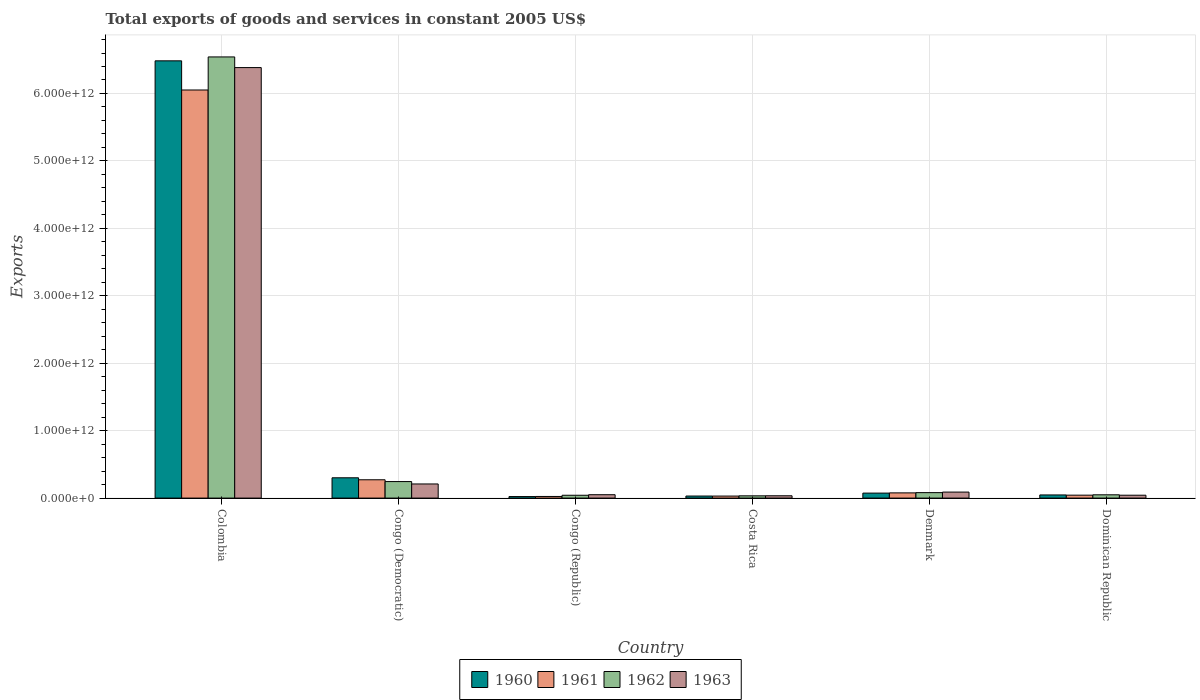Are the number of bars per tick equal to the number of legend labels?
Your answer should be very brief. Yes. Are the number of bars on each tick of the X-axis equal?
Your answer should be compact. Yes. How many bars are there on the 4th tick from the left?
Provide a short and direct response. 4. How many bars are there on the 1st tick from the right?
Your answer should be very brief. 4. What is the label of the 2nd group of bars from the left?
Provide a short and direct response. Congo (Democratic). What is the total exports of goods and services in 1962 in Denmark?
Offer a terse response. 8.10e+1. Across all countries, what is the maximum total exports of goods and services in 1961?
Provide a short and direct response. 6.05e+12. Across all countries, what is the minimum total exports of goods and services in 1960?
Offer a terse response. 2.25e+1. In which country was the total exports of goods and services in 1961 minimum?
Your response must be concise. Congo (Republic). What is the total total exports of goods and services in 1960 in the graph?
Your answer should be very brief. 6.96e+12. What is the difference between the total exports of goods and services in 1961 in Colombia and that in Denmark?
Keep it short and to the point. 5.97e+12. What is the difference between the total exports of goods and services in 1961 in Congo (Democratic) and the total exports of goods and services in 1962 in Congo (Republic)?
Your answer should be very brief. 2.30e+11. What is the average total exports of goods and services in 1960 per country?
Your answer should be very brief. 1.16e+12. What is the difference between the total exports of goods and services of/in 1962 and total exports of goods and services of/in 1963 in Costa Rica?
Your response must be concise. -8.49e+08. In how many countries, is the total exports of goods and services in 1963 greater than 200000000000 US$?
Offer a very short reply. 2. What is the ratio of the total exports of goods and services in 1963 in Congo (Democratic) to that in Denmark?
Make the answer very short. 2.35. Is the difference between the total exports of goods and services in 1962 in Denmark and Dominican Republic greater than the difference between the total exports of goods and services in 1963 in Denmark and Dominican Republic?
Your answer should be very brief. No. What is the difference between the highest and the second highest total exports of goods and services in 1960?
Offer a terse response. 6.41e+12. What is the difference between the highest and the lowest total exports of goods and services in 1962?
Give a very brief answer. 6.51e+12. In how many countries, is the total exports of goods and services in 1961 greater than the average total exports of goods and services in 1961 taken over all countries?
Your response must be concise. 1. Is the sum of the total exports of goods and services in 1963 in Costa Rica and Denmark greater than the maximum total exports of goods and services in 1960 across all countries?
Your answer should be very brief. No. What does the 4th bar from the left in Colombia represents?
Offer a terse response. 1963. How many bars are there?
Provide a succinct answer. 24. How many countries are there in the graph?
Make the answer very short. 6. What is the difference between two consecutive major ticks on the Y-axis?
Your answer should be very brief. 1.00e+12. Where does the legend appear in the graph?
Provide a succinct answer. Bottom center. How are the legend labels stacked?
Your response must be concise. Horizontal. What is the title of the graph?
Your response must be concise. Total exports of goods and services in constant 2005 US$. What is the label or title of the Y-axis?
Offer a very short reply. Exports. What is the Exports of 1960 in Colombia?
Provide a succinct answer. 6.48e+12. What is the Exports in 1961 in Colombia?
Your response must be concise. 6.05e+12. What is the Exports of 1962 in Colombia?
Your answer should be very brief. 6.54e+12. What is the Exports in 1963 in Colombia?
Provide a succinct answer. 6.38e+12. What is the Exports in 1960 in Congo (Democratic)?
Give a very brief answer. 3.01e+11. What is the Exports in 1961 in Congo (Democratic)?
Give a very brief answer. 2.72e+11. What is the Exports in 1962 in Congo (Democratic)?
Give a very brief answer. 2.45e+11. What is the Exports of 1963 in Congo (Democratic)?
Your response must be concise. 2.09e+11. What is the Exports in 1960 in Congo (Republic)?
Your answer should be compact. 2.25e+1. What is the Exports of 1961 in Congo (Republic)?
Give a very brief answer. 2.42e+1. What is the Exports of 1962 in Congo (Republic)?
Keep it short and to the point. 4.20e+1. What is the Exports of 1963 in Congo (Republic)?
Your answer should be compact. 5.01e+1. What is the Exports of 1960 in Costa Rica?
Your response must be concise. 3.05e+1. What is the Exports in 1961 in Costa Rica?
Ensure brevity in your answer.  3.00e+1. What is the Exports in 1962 in Costa Rica?
Keep it short and to the point. 3.35e+1. What is the Exports in 1963 in Costa Rica?
Keep it short and to the point. 3.44e+1. What is the Exports of 1960 in Denmark?
Provide a succinct answer. 7.40e+1. What is the Exports of 1961 in Denmark?
Make the answer very short. 7.72e+1. What is the Exports of 1962 in Denmark?
Ensure brevity in your answer.  8.10e+1. What is the Exports in 1963 in Denmark?
Your answer should be very brief. 8.91e+1. What is the Exports in 1960 in Dominican Republic?
Offer a terse response. 4.67e+1. What is the Exports of 1961 in Dominican Republic?
Keep it short and to the point. 4.34e+1. What is the Exports in 1962 in Dominican Republic?
Provide a short and direct response. 4.87e+1. What is the Exports in 1963 in Dominican Republic?
Make the answer very short. 4.28e+1. Across all countries, what is the maximum Exports of 1960?
Keep it short and to the point. 6.48e+12. Across all countries, what is the maximum Exports of 1961?
Ensure brevity in your answer.  6.05e+12. Across all countries, what is the maximum Exports in 1962?
Your answer should be very brief. 6.54e+12. Across all countries, what is the maximum Exports in 1963?
Offer a terse response. 6.38e+12. Across all countries, what is the minimum Exports of 1960?
Your answer should be compact. 2.25e+1. Across all countries, what is the minimum Exports of 1961?
Give a very brief answer. 2.42e+1. Across all countries, what is the minimum Exports of 1962?
Your response must be concise. 3.35e+1. Across all countries, what is the minimum Exports in 1963?
Your response must be concise. 3.44e+1. What is the total Exports of 1960 in the graph?
Your answer should be very brief. 6.96e+12. What is the total Exports of 1961 in the graph?
Offer a very short reply. 6.50e+12. What is the total Exports of 1962 in the graph?
Make the answer very short. 6.99e+12. What is the total Exports of 1963 in the graph?
Your response must be concise. 6.81e+12. What is the difference between the Exports in 1960 in Colombia and that in Congo (Democratic)?
Provide a short and direct response. 6.18e+12. What is the difference between the Exports in 1961 in Colombia and that in Congo (Democratic)?
Your response must be concise. 5.78e+12. What is the difference between the Exports of 1962 in Colombia and that in Congo (Democratic)?
Make the answer very short. 6.30e+12. What is the difference between the Exports in 1963 in Colombia and that in Congo (Democratic)?
Provide a short and direct response. 6.17e+12. What is the difference between the Exports in 1960 in Colombia and that in Congo (Republic)?
Keep it short and to the point. 6.46e+12. What is the difference between the Exports in 1961 in Colombia and that in Congo (Republic)?
Your answer should be compact. 6.03e+12. What is the difference between the Exports of 1962 in Colombia and that in Congo (Republic)?
Your answer should be compact. 6.50e+12. What is the difference between the Exports in 1963 in Colombia and that in Congo (Republic)?
Give a very brief answer. 6.33e+12. What is the difference between the Exports in 1960 in Colombia and that in Costa Rica?
Keep it short and to the point. 6.45e+12. What is the difference between the Exports in 1961 in Colombia and that in Costa Rica?
Offer a very short reply. 6.02e+12. What is the difference between the Exports of 1962 in Colombia and that in Costa Rica?
Your response must be concise. 6.51e+12. What is the difference between the Exports in 1963 in Colombia and that in Costa Rica?
Your answer should be very brief. 6.35e+12. What is the difference between the Exports of 1960 in Colombia and that in Denmark?
Ensure brevity in your answer.  6.41e+12. What is the difference between the Exports in 1961 in Colombia and that in Denmark?
Offer a terse response. 5.97e+12. What is the difference between the Exports of 1962 in Colombia and that in Denmark?
Your answer should be compact. 6.46e+12. What is the difference between the Exports in 1963 in Colombia and that in Denmark?
Make the answer very short. 6.29e+12. What is the difference between the Exports in 1960 in Colombia and that in Dominican Republic?
Your response must be concise. 6.44e+12. What is the difference between the Exports in 1961 in Colombia and that in Dominican Republic?
Give a very brief answer. 6.01e+12. What is the difference between the Exports of 1962 in Colombia and that in Dominican Republic?
Ensure brevity in your answer.  6.49e+12. What is the difference between the Exports of 1963 in Colombia and that in Dominican Republic?
Offer a very short reply. 6.34e+12. What is the difference between the Exports of 1960 in Congo (Democratic) and that in Congo (Republic)?
Give a very brief answer. 2.79e+11. What is the difference between the Exports of 1961 in Congo (Democratic) and that in Congo (Republic)?
Your answer should be compact. 2.48e+11. What is the difference between the Exports of 1962 in Congo (Democratic) and that in Congo (Republic)?
Keep it short and to the point. 2.03e+11. What is the difference between the Exports of 1963 in Congo (Democratic) and that in Congo (Republic)?
Make the answer very short. 1.59e+11. What is the difference between the Exports of 1960 in Congo (Democratic) and that in Costa Rica?
Your answer should be compact. 2.71e+11. What is the difference between the Exports of 1961 in Congo (Democratic) and that in Costa Rica?
Your answer should be very brief. 2.42e+11. What is the difference between the Exports in 1962 in Congo (Democratic) and that in Costa Rica?
Offer a very short reply. 2.11e+11. What is the difference between the Exports in 1963 in Congo (Democratic) and that in Costa Rica?
Offer a terse response. 1.75e+11. What is the difference between the Exports in 1960 in Congo (Democratic) and that in Denmark?
Keep it short and to the point. 2.27e+11. What is the difference between the Exports of 1961 in Congo (Democratic) and that in Denmark?
Offer a very short reply. 1.95e+11. What is the difference between the Exports of 1962 in Congo (Democratic) and that in Denmark?
Your response must be concise. 1.64e+11. What is the difference between the Exports of 1963 in Congo (Democratic) and that in Denmark?
Your answer should be very brief. 1.20e+11. What is the difference between the Exports in 1960 in Congo (Democratic) and that in Dominican Republic?
Your answer should be very brief. 2.54e+11. What is the difference between the Exports of 1961 in Congo (Democratic) and that in Dominican Republic?
Your response must be concise. 2.28e+11. What is the difference between the Exports of 1962 in Congo (Democratic) and that in Dominican Republic?
Your answer should be very brief. 1.96e+11. What is the difference between the Exports of 1963 in Congo (Democratic) and that in Dominican Republic?
Offer a very short reply. 1.67e+11. What is the difference between the Exports of 1960 in Congo (Republic) and that in Costa Rica?
Offer a very short reply. -7.99e+09. What is the difference between the Exports in 1961 in Congo (Republic) and that in Costa Rica?
Your response must be concise. -5.74e+09. What is the difference between the Exports in 1962 in Congo (Republic) and that in Costa Rica?
Your answer should be very brief. 8.51e+09. What is the difference between the Exports in 1963 in Congo (Republic) and that in Costa Rica?
Offer a very short reply. 1.57e+1. What is the difference between the Exports in 1960 in Congo (Republic) and that in Denmark?
Make the answer very short. -5.15e+1. What is the difference between the Exports of 1961 in Congo (Republic) and that in Denmark?
Provide a succinct answer. -5.30e+1. What is the difference between the Exports of 1962 in Congo (Republic) and that in Denmark?
Provide a succinct answer. -3.90e+1. What is the difference between the Exports of 1963 in Congo (Republic) and that in Denmark?
Offer a terse response. -3.90e+1. What is the difference between the Exports of 1960 in Congo (Republic) and that in Dominican Republic?
Ensure brevity in your answer.  -2.42e+1. What is the difference between the Exports of 1961 in Congo (Republic) and that in Dominican Republic?
Offer a very short reply. -1.92e+1. What is the difference between the Exports of 1962 in Congo (Republic) and that in Dominican Republic?
Provide a short and direct response. -6.63e+09. What is the difference between the Exports in 1963 in Congo (Republic) and that in Dominican Republic?
Provide a short and direct response. 7.33e+09. What is the difference between the Exports in 1960 in Costa Rica and that in Denmark?
Your answer should be very brief. -4.35e+1. What is the difference between the Exports of 1961 in Costa Rica and that in Denmark?
Give a very brief answer. -4.73e+1. What is the difference between the Exports in 1962 in Costa Rica and that in Denmark?
Your answer should be compact. -4.75e+1. What is the difference between the Exports of 1963 in Costa Rica and that in Denmark?
Make the answer very short. -5.47e+1. What is the difference between the Exports of 1960 in Costa Rica and that in Dominican Republic?
Ensure brevity in your answer.  -1.62e+1. What is the difference between the Exports of 1961 in Costa Rica and that in Dominican Republic?
Provide a short and direct response. -1.35e+1. What is the difference between the Exports in 1962 in Costa Rica and that in Dominican Republic?
Provide a succinct answer. -1.51e+1. What is the difference between the Exports in 1963 in Costa Rica and that in Dominican Republic?
Offer a very short reply. -8.40e+09. What is the difference between the Exports of 1960 in Denmark and that in Dominican Republic?
Make the answer very short. 2.73e+1. What is the difference between the Exports in 1961 in Denmark and that in Dominican Republic?
Make the answer very short. 3.38e+1. What is the difference between the Exports in 1962 in Denmark and that in Dominican Republic?
Your answer should be compact. 3.23e+1. What is the difference between the Exports of 1963 in Denmark and that in Dominican Republic?
Your answer should be very brief. 4.63e+1. What is the difference between the Exports of 1960 in Colombia and the Exports of 1961 in Congo (Democratic)?
Your answer should be compact. 6.21e+12. What is the difference between the Exports of 1960 in Colombia and the Exports of 1962 in Congo (Democratic)?
Offer a terse response. 6.24e+12. What is the difference between the Exports of 1960 in Colombia and the Exports of 1963 in Congo (Democratic)?
Keep it short and to the point. 6.27e+12. What is the difference between the Exports of 1961 in Colombia and the Exports of 1962 in Congo (Democratic)?
Ensure brevity in your answer.  5.81e+12. What is the difference between the Exports in 1961 in Colombia and the Exports in 1963 in Congo (Democratic)?
Provide a short and direct response. 5.84e+12. What is the difference between the Exports of 1962 in Colombia and the Exports of 1963 in Congo (Democratic)?
Your answer should be compact. 6.33e+12. What is the difference between the Exports in 1960 in Colombia and the Exports in 1961 in Congo (Republic)?
Offer a very short reply. 6.46e+12. What is the difference between the Exports of 1960 in Colombia and the Exports of 1962 in Congo (Republic)?
Give a very brief answer. 6.44e+12. What is the difference between the Exports of 1960 in Colombia and the Exports of 1963 in Congo (Republic)?
Your answer should be very brief. 6.43e+12. What is the difference between the Exports of 1961 in Colombia and the Exports of 1962 in Congo (Republic)?
Offer a terse response. 6.01e+12. What is the difference between the Exports of 1961 in Colombia and the Exports of 1963 in Congo (Republic)?
Keep it short and to the point. 6.00e+12. What is the difference between the Exports of 1962 in Colombia and the Exports of 1963 in Congo (Republic)?
Your response must be concise. 6.49e+12. What is the difference between the Exports in 1960 in Colombia and the Exports in 1961 in Costa Rica?
Offer a very short reply. 6.45e+12. What is the difference between the Exports of 1960 in Colombia and the Exports of 1962 in Costa Rica?
Ensure brevity in your answer.  6.45e+12. What is the difference between the Exports of 1960 in Colombia and the Exports of 1963 in Costa Rica?
Your answer should be very brief. 6.45e+12. What is the difference between the Exports of 1961 in Colombia and the Exports of 1962 in Costa Rica?
Give a very brief answer. 6.02e+12. What is the difference between the Exports in 1961 in Colombia and the Exports in 1963 in Costa Rica?
Provide a short and direct response. 6.02e+12. What is the difference between the Exports of 1962 in Colombia and the Exports of 1963 in Costa Rica?
Your answer should be very brief. 6.51e+12. What is the difference between the Exports of 1960 in Colombia and the Exports of 1961 in Denmark?
Offer a very short reply. 6.41e+12. What is the difference between the Exports of 1960 in Colombia and the Exports of 1962 in Denmark?
Make the answer very short. 6.40e+12. What is the difference between the Exports in 1960 in Colombia and the Exports in 1963 in Denmark?
Provide a short and direct response. 6.40e+12. What is the difference between the Exports in 1961 in Colombia and the Exports in 1962 in Denmark?
Ensure brevity in your answer.  5.97e+12. What is the difference between the Exports in 1961 in Colombia and the Exports in 1963 in Denmark?
Your answer should be very brief. 5.96e+12. What is the difference between the Exports in 1962 in Colombia and the Exports in 1963 in Denmark?
Provide a succinct answer. 6.45e+12. What is the difference between the Exports in 1960 in Colombia and the Exports in 1961 in Dominican Republic?
Ensure brevity in your answer.  6.44e+12. What is the difference between the Exports of 1960 in Colombia and the Exports of 1962 in Dominican Republic?
Offer a terse response. 6.44e+12. What is the difference between the Exports of 1960 in Colombia and the Exports of 1963 in Dominican Republic?
Keep it short and to the point. 6.44e+12. What is the difference between the Exports in 1961 in Colombia and the Exports in 1962 in Dominican Republic?
Make the answer very short. 6.00e+12. What is the difference between the Exports in 1961 in Colombia and the Exports in 1963 in Dominican Republic?
Offer a terse response. 6.01e+12. What is the difference between the Exports in 1962 in Colombia and the Exports in 1963 in Dominican Republic?
Ensure brevity in your answer.  6.50e+12. What is the difference between the Exports in 1960 in Congo (Democratic) and the Exports in 1961 in Congo (Republic)?
Provide a succinct answer. 2.77e+11. What is the difference between the Exports in 1960 in Congo (Democratic) and the Exports in 1962 in Congo (Republic)?
Provide a succinct answer. 2.59e+11. What is the difference between the Exports in 1960 in Congo (Democratic) and the Exports in 1963 in Congo (Republic)?
Ensure brevity in your answer.  2.51e+11. What is the difference between the Exports of 1961 in Congo (Democratic) and the Exports of 1962 in Congo (Republic)?
Offer a terse response. 2.30e+11. What is the difference between the Exports of 1961 in Congo (Democratic) and the Exports of 1963 in Congo (Republic)?
Provide a short and direct response. 2.22e+11. What is the difference between the Exports of 1962 in Congo (Democratic) and the Exports of 1963 in Congo (Republic)?
Your response must be concise. 1.95e+11. What is the difference between the Exports in 1960 in Congo (Democratic) and the Exports in 1961 in Costa Rica?
Provide a succinct answer. 2.71e+11. What is the difference between the Exports of 1960 in Congo (Democratic) and the Exports of 1962 in Costa Rica?
Your answer should be compact. 2.68e+11. What is the difference between the Exports in 1960 in Congo (Democratic) and the Exports in 1963 in Costa Rica?
Make the answer very short. 2.67e+11. What is the difference between the Exports of 1961 in Congo (Democratic) and the Exports of 1962 in Costa Rica?
Your answer should be compact. 2.38e+11. What is the difference between the Exports in 1961 in Congo (Democratic) and the Exports in 1963 in Costa Rica?
Make the answer very short. 2.37e+11. What is the difference between the Exports in 1962 in Congo (Democratic) and the Exports in 1963 in Costa Rica?
Your answer should be compact. 2.11e+11. What is the difference between the Exports of 1960 in Congo (Democratic) and the Exports of 1961 in Denmark?
Keep it short and to the point. 2.24e+11. What is the difference between the Exports of 1960 in Congo (Democratic) and the Exports of 1962 in Denmark?
Give a very brief answer. 2.20e+11. What is the difference between the Exports in 1960 in Congo (Democratic) and the Exports in 1963 in Denmark?
Your response must be concise. 2.12e+11. What is the difference between the Exports in 1961 in Congo (Democratic) and the Exports in 1962 in Denmark?
Offer a very short reply. 1.91e+11. What is the difference between the Exports of 1961 in Congo (Democratic) and the Exports of 1963 in Denmark?
Your response must be concise. 1.83e+11. What is the difference between the Exports in 1962 in Congo (Democratic) and the Exports in 1963 in Denmark?
Your response must be concise. 1.56e+11. What is the difference between the Exports of 1960 in Congo (Democratic) and the Exports of 1961 in Dominican Republic?
Make the answer very short. 2.58e+11. What is the difference between the Exports of 1960 in Congo (Democratic) and the Exports of 1962 in Dominican Republic?
Provide a succinct answer. 2.52e+11. What is the difference between the Exports in 1960 in Congo (Democratic) and the Exports in 1963 in Dominican Republic?
Keep it short and to the point. 2.58e+11. What is the difference between the Exports of 1961 in Congo (Democratic) and the Exports of 1962 in Dominican Republic?
Make the answer very short. 2.23e+11. What is the difference between the Exports of 1961 in Congo (Democratic) and the Exports of 1963 in Dominican Republic?
Your response must be concise. 2.29e+11. What is the difference between the Exports of 1962 in Congo (Democratic) and the Exports of 1963 in Dominican Republic?
Your answer should be compact. 2.02e+11. What is the difference between the Exports of 1960 in Congo (Republic) and the Exports of 1961 in Costa Rica?
Provide a short and direct response. -7.43e+09. What is the difference between the Exports of 1960 in Congo (Republic) and the Exports of 1962 in Costa Rica?
Give a very brief answer. -1.10e+1. What is the difference between the Exports of 1960 in Congo (Republic) and the Exports of 1963 in Costa Rica?
Offer a very short reply. -1.19e+1. What is the difference between the Exports of 1961 in Congo (Republic) and the Exports of 1962 in Costa Rica?
Give a very brief answer. -9.32e+09. What is the difference between the Exports of 1961 in Congo (Republic) and the Exports of 1963 in Costa Rica?
Give a very brief answer. -1.02e+1. What is the difference between the Exports in 1962 in Congo (Republic) and the Exports in 1963 in Costa Rica?
Provide a succinct answer. 7.66e+09. What is the difference between the Exports in 1960 in Congo (Republic) and the Exports in 1961 in Denmark?
Keep it short and to the point. -5.47e+1. What is the difference between the Exports of 1960 in Congo (Republic) and the Exports of 1962 in Denmark?
Offer a terse response. -5.85e+1. What is the difference between the Exports of 1960 in Congo (Republic) and the Exports of 1963 in Denmark?
Provide a succinct answer. -6.66e+1. What is the difference between the Exports of 1961 in Congo (Republic) and the Exports of 1962 in Denmark?
Ensure brevity in your answer.  -5.68e+1. What is the difference between the Exports of 1961 in Congo (Republic) and the Exports of 1963 in Denmark?
Make the answer very short. -6.49e+1. What is the difference between the Exports of 1962 in Congo (Republic) and the Exports of 1963 in Denmark?
Offer a terse response. -4.70e+1. What is the difference between the Exports of 1960 in Congo (Republic) and the Exports of 1961 in Dominican Republic?
Your answer should be compact. -2.09e+1. What is the difference between the Exports of 1960 in Congo (Republic) and the Exports of 1962 in Dominican Republic?
Keep it short and to the point. -2.62e+1. What is the difference between the Exports of 1960 in Congo (Republic) and the Exports of 1963 in Dominican Republic?
Provide a succinct answer. -2.03e+1. What is the difference between the Exports in 1961 in Congo (Republic) and the Exports in 1962 in Dominican Republic?
Provide a short and direct response. -2.45e+1. What is the difference between the Exports of 1961 in Congo (Republic) and the Exports of 1963 in Dominican Republic?
Offer a terse response. -1.86e+1. What is the difference between the Exports of 1962 in Congo (Republic) and the Exports of 1963 in Dominican Republic?
Your answer should be very brief. -7.40e+08. What is the difference between the Exports in 1960 in Costa Rica and the Exports in 1961 in Denmark?
Ensure brevity in your answer.  -4.67e+1. What is the difference between the Exports of 1960 in Costa Rica and the Exports of 1962 in Denmark?
Your answer should be compact. -5.05e+1. What is the difference between the Exports of 1960 in Costa Rica and the Exports of 1963 in Denmark?
Ensure brevity in your answer.  -5.86e+1. What is the difference between the Exports in 1961 in Costa Rica and the Exports in 1962 in Denmark?
Make the answer very short. -5.10e+1. What is the difference between the Exports in 1961 in Costa Rica and the Exports in 1963 in Denmark?
Your answer should be very brief. -5.91e+1. What is the difference between the Exports in 1962 in Costa Rica and the Exports in 1963 in Denmark?
Provide a short and direct response. -5.55e+1. What is the difference between the Exports of 1960 in Costa Rica and the Exports of 1961 in Dominican Republic?
Your answer should be compact. -1.29e+1. What is the difference between the Exports of 1960 in Costa Rica and the Exports of 1962 in Dominican Republic?
Your response must be concise. -1.82e+1. What is the difference between the Exports of 1960 in Costa Rica and the Exports of 1963 in Dominican Republic?
Offer a terse response. -1.23e+1. What is the difference between the Exports in 1961 in Costa Rica and the Exports in 1962 in Dominican Republic?
Ensure brevity in your answer.  -1.87e+1. What is the difference between the Exports of 1961 in Costa Rica and the Exports of 1963 in Dominican Republic?
Offer a very short reply. -1.28e+1. What is the difference between the Exports of 1962 in Costa Rica and the Exports of 1963 in Dominican Republic?
Keep it short and to the point. -9.25e+09. What is the difference between the Exports of 1960 in Denmark and the Exports of 1961 in Dominican Republic?
Ensure brevity in your answer.  3.06e+1. What is the difference between the Exports of 1960 in Denmark and the Exports of 1962 in Dominican Republic?
Make the answer very short. 2.54e+1. What is the difference between the Exports of 1960 in Denmark and the Exports of 1963 in Dominican Republic?
Give a very brief answer. 3.13e+1. What is the difference between the Exports in 1961 in Denmark and the Exports in 1962 in Dominican Republic?
Ensure brevity in your answer.  2.85e+1. What is the difference between the Exports of 1961 in Denmark and the Exports of 1963 in Dominican Republic?
Give a very brief answer. 3.44e+1. What is the difference between the Exports of 1962 in Denmark and the Exports of 1963 in Dominican Republic?
Offer a terse response. 3.82e+1. What is the average Exports of 1960 per country?
Your answer should be very brief. 1.16e+12. What is the average Exports of 1961 per country?
Ensure brevity in your answer.  1.08e+12. What is the average Exports of 1962 per country?
Provide a short and direct response. 1.17e+12. What is the average Exports in 1963 per country?
Provide a succinct answer. 1.13e+12. What is the difference between the Exports of 1960 and Exports of 1961 in Colombia?
Provide a short and direct response. 4.32e+11. What is the difference between the Exports in 1960 and Exports in 1962 in Colombia?
Give a very brief answer. -5.79e+1. What is the difference between the Exports of 1960 and Exports of 1963 in Colombia?
Give a very brief answer. 1.00e+11. What is the difference between the Exports of 1961 and Exports of 1962 in Colombia?
Your answer should be compact. -4.90e+11. What is the difference between the Exports in 1961 and Exports in 1963 in Colombia?
Make the answer very short. -3.32e+11. What is the difference between the Exports of 1962 and Exports of 1963 in Colombia?
Provide a short and direct response. 1.58e+11. What is the difference between the Exports of 1960 and Exports of 1961 in Congo (Democratic)?
Provide a succinct answer. 2.94e+1. What is the difference between the Exports in 1960 and Exports in 1962 in Congo (Democratic)?
Ensure brevity in your answer.  5.61e+1. What is the difference between the Exports of 1960 and Exports of 1963 in Congo (Democratic)?
Make the answer very short. 9.17e+1. What is the difference between the Exports in 1961 and Exports in 1962 in Congo (Democratic)?
Ensure brevity in your answer.  2.67e+1. What is the difference between the Exports in 1961 and Exports in 1963 in Congo (Democratic)?
Keep it short and to the point. 6.23e+1. What is the difference between the Exports of 1962 and Exports of 1963 in Congo (Democratic)?
Your answer should be compact. 3.56e+1. What is the difference between the Exports of 1960 and Exports of 1961 in Congo (Republic)?
Offer a very short reply. -1.69e+09. What is the difference between the Exports of 1960 and Exports of 1962 in Congo (Republic)?
Keep it short and to the point. -1.95e+1. What is the difference between the Exports in 1960 and Exports in 1963 in Congo (Republic)?
Make the answer very short. -2.76e+1. What is the difference between the Exports of 1961 and Exports of 1962 in Congo (Republic)?
Your response must be concise. -1.78e+1. What is the difference between the Exports in 1961 and Exports in 1963 in Congo (Republic)?
Offer a terse response. -2.59e+1. What is the difference between the Exports in 1962 and Exports in 1963 in Congo (Republic)?
Your response must be concise. -8.07e+09. What is the difference between the Exports of 1960 and Exports of 1961 in Costa Rica?
Offer a terse response. 5.60e+08. What is the difference between the Exports in 1960 and Exports in 1962 in Costa Rica?
Make the answer very short. -3.02e+09. What is the difference between the Exports of 1960 and Exports of 1963 in Costa Rica?
Your response must be concise. -3.87e+09. What is the difference between the Exports in 1961 and Exports in 1962 in Costa Rica?
Offer a very short reply. -3.58e+09. What is the difference between the Exports of 1961 and Exports of 1963 in Costa Rica?
Make the answer very short. -4.43e+09. What is the difference between the Exports in 1962 and Exports in 1963 in Costa Rica?
Offer a very short reply. -8.49e+08. What is the difference between the Exports of 1960 and Exports of 1961 in Denmark?
Provide a succinct answer. -3.17e+09. What is the difference between the Exports in 1960 and Exports in 1962 in Denmark?
Ensure brevity in your answer.  -6.96e+09. What is the difference between the Exports of 1960 and Exports of 1963 in Denmark?
Your answer should be compact. -1.50e+1. What is the difference between the Exports of 1961 and Exports of 1962 in Denmark?
Your response must be concise. -3.79e+09. What is the difference between the Exports in 1961 and Exports in 1963 in Denmark?
Give a very brief answer. -1.19e+1. What is the difference between the Exports of 1962 and Exports of 1963 in Denmark?
Give a very brief answer. -8.08e+09. What is the difference between the Exports of 1960 and Exports of 1961 in Dominican Republic?
Keep it short and to the point. 3.29e+09. What is the difference between the Exports in 1960 and Exports in 1962 in Dominican Republic?
Give a very brief answer. -1.98e+09. What is the difference between the Exports in 1960 and Exports in 1963 in Dominican Republic?
Provide a short and direct response. 3.92e+09. What is the difference between the Exports in 1961 and Exports in 1962 in Dominican Republic?
Provide a succinct answer. -5.27e+09. What is the difference between the Exports in 1961 and Exports in 1963 in Dominican Republic?
Offer a very short reply. 6.26e+08. What is the difference between the Exports of 1962 and Exports of 1963 in Dominican Republic?
Give a very brief answer. 5.89e+09. What is the ratio of the Exports in 1960 in Colombia to that in Congo (Democratic)?
Your answer should be compact. 21.53. What is the ratio of the Exports in 1961 in Colombia to that in Congo (Democratic)?
Ensure brevity in your answer.  22.27. What is the ratio of the Exports in 1962 in Colombia to that in Congo (Democratic)?
Provide a succinct answer. 26.7. What is the ratio of the Exports of 1963 in Colombia to that in Congo (Democratic)?
Ensure brevity in your answer.  30.48. What is the ratio of the Exports of 1960 in Colombia to that in Congo (Republic)?
Offer a very short reply. 287.84. What is the ratio of the Exports in 1961 in Colombia to that in Congo (Republic)?
Provide a short and direct response. 249.91. What is the ratio of the Exports in 1962 in Colombia to that in Congo (Republic)?
Ensure brevity in your answer.  155.58. What is the ratio of the Exports of 1963 in Colombia to that in Congo (Republic)?
Offer a very short reply. 127.37. What is the ratio of the Exports in 1960 in Colombia to that in Costa Rica?
Your answer should be compact. 212.46. What is the ratio of the Exports in 1961 in Colombia to that in Costa Rica?
Offer a very short reply. 202. What is the ratio of the Exports of 1962 in Colombia to that in Costa Rica?
Give a very brief answer. 195.05. What is the ratio of the Exports in 1963 in Colombia to that in Costa Rica?
Make the answer very short. 185.65. What is the ratio of the Exports of 1960 in Colombia to that in Denmark?
Keep it short and to the point. 87.57. What is the ratio of the Exports in 1961 in Colombia to that in Denmark?
Give a very brief answer. 78.38. What is the ratio of the Exports of 1962 in Colombia to that in Denmark?
Your answer should be very brief. 80.76. What is the ratio of the Exports in 1963 in Colombia to that in Denmark?
Your answer should be compact. 71.66. What is the ratio of the Exports in 1960 in Colombia to that in Dominican Republic?
Provide a succinct answer. 138.83. What is the ratio of the Exports in 1961 in Colombia to that in Dominican Republic?
Provide a succinct answer. 139.39. What is the ratio of the Exports in 1962 in Colombia to that in Dominican Republic?
Your answer should be compact. 134.38. What is the ratio of the Exports of 1963 in Colombia to that in Dominican Republic?
Offer a terse response. 149.2. What is the ratio of the Exports in 1960 in Congo (Democratic) to that in Congo (Republic)?
Keep it short and to the point. 13.37. What is the ratio of the Exports of 1961 in Congo (Democratic) to that in Congo (Republic)?
Provide a succinct answer. 11.22. What is the ratio of the Exports of 1962 in Congo (Democratic) to that in Congo (Republic)?
Provide a short and direct response. 5.83. What is the ratio of the Exports in 1963 in Congo (Democratic) to that in Congo (Republic)?
Offer a terse response. 4.18. What is the ratio of the Exports of 1960 in Congo (Democratic) to that in Costa Rica?
Make the answer very short. 9.87. What is the ratio of the Exports in 1961 in Congo (Democratic) to that in Costa Rica?
Your answer should be very brief. 9.07. What is the ratio of the Exports of 1962 in Congo (Democratic) to that in Costa Rica?
Give a very brief answer. 7.31. What is the ratio of the Exports of 1963 in Congo (Democratic) to that in Costa Rica?
Offer a very short reply. 6.09. What is the ratio of the Exports of 1960 in Congo (Democratic) to that in Denmark?
Keep it short and to the point. 4.07. What is the ratio of the Exports in 1961 in Congo (Democratic) to that in Denmark?
Make the answer very short. 3.52. What is the ratio of the Exports in 1962 in Congo (Democratic) to that in Denmark?
Offer a very short reply. 3.02. What is the ratio of the Exports in 1963 in Congo (Democratic) to that in Denmark?
Ensure brevity in your answer.  2.35. What is the ratio of the Exports of 1960 in Congo (Democratic) to that in Dominican Republic?
Offer a very short reply. 6.45. What is the ratio of the Exports of 1961 in Congo (Democratic) to that in Dominican Republic?
Give a very brief answer. 6.26. What is the ratio of the Exports of 1962 in Congo (Democratic) to that in Dominican Republic?
Your response must be concise. 5.03. What is the ratio of the Exports of 1963 in Congo (Democratic) to that in Dominican Republic?
Make the answer very short. 4.89. What is the ratio of the Exports of 1960 in Congo (Republic) to that in Costa Rica?
Give a very brief answer. 0.74. What is the ratio of the Exports in 1961 in Congo (Republic) to that in Costa Rica?
Your answer should be very brief. 0.81. What is the ratio of the Exports in 1962 in Congo (Republic) to that in Costa Rica?
Ensure brevity in your answer.  1.25. What is the ratio of the Exports in 1963 in Congo (Republic) to that in Costa Rica?
Provide a succinct answer. 1.46. What is the ratio of the Exports of 1960 in Congo (Republic) to that in Denmark?
Your response must be concise. 0.3. What is the ratio of the Exports of 1961 in Congo (Republic) to that in Denmark?
Provide a succinct answer. 0.31. What is the ratio of the Exports of 1962 in Congo (Republic) to that in Denmark?
Give a very brief answer. 0.52. What is the ratio of the Exports in 1963 in Congo (Republic) to that in Denmark?
Provide a short and direct response. 0.56. What is the ratio of the Exports in 1960 in Congo (Republic) to that in Dominican Republic?
Provide a short and direct response. 0.48. What is the ratio of the Exports of 1961 in Congo (Republic) to that in Dominican Republic?
Provide a short and direct response. 0.56. What is the ratio of the Exports in 1962 in Congo (Republic) to that in Dominican Republic?
Provide a short and direct response. 0.86. What is the ratio of the Exports in 1963 in Congo (Republic) to that in Dominican Republic?
Provide a short and direct response. 1.17. What is the ratio of the Exports of 1960 in Costa Rica to that in Denmark?
Keep it short and to the point. 0.41. What is the ratio of the Exports of 1961 in Costa Rica to that in Denmark?
Offer a very short reply. 0.39. What is the ratio of the Exports in 1962 in Costa Rica to that in Denmark?
Provide a short and direct response. 0.41. What is the ratio of the Exports in 1963 in Costa Rica to that in Denmark?
Your response must be concise. 0.39. What is the ratio of the Exports in 1960 in Costa Rica to that in Dominican Republic?
Provide a succinct answer. 0.65. What is the ratio of the Exports in 1961 in Costa Rica to that in Dominican Republic?
Provide a short and direct response. 0.69. What is the ratio of the Exports of 1962 in Costa Rica to that in Dominican Republic?
Your answer should be very brief. 0.69. What is the ratio of the Exports of 1963 in Costa Rica to that in Dominican Republic?
Provide a succinct answer. 0.8. What is the ratio of the Exports in 1960 in Denmark to that in Dominican Republic?
Make the answer very short. 1.59. What is the ratio of the Exports of 1961 in Denmark to that in Dominican Republic?
Give a very brief answer. 1.78. What is the ratio of the Exports in 1962 in Denmark to that in Dominican Republic?
Your answer should be compact. 1.66. What is the ratio of the Exports of 1963 in Denmark to that in Dominican Republic?
Provide a succinct answer. 2.08. What is the difference between the highest and the second highest Exports in 1960?
Provide a short and direct response. 6.18e+12. What is the difference between the highest and the second highest Exports in 1961?
Provide a succinct answer. 5.78e+12. What is the difference between the highest and the second highest Exports of 1962?
Offer a very short reply. 6.30e+12. What is the difference between the highest and the second highest Exports of 1963?
Ensure brevity in your answer.  6.17e+12. What is the difference between the highest and the lowest Exports in 1960?
Offer a terse response. 6.46e+12. What is the difference between the highest and the lowest Exports in 1961?
Your answer should be very brief. 6.03e+12. What is the difference between the highest and the lowest Exports of 1962?
Offer a terse response. 6.51e+12. What is the difference between the highest and the lowest Exports of 1963?
Offer a terse response. 6.35e+12. 